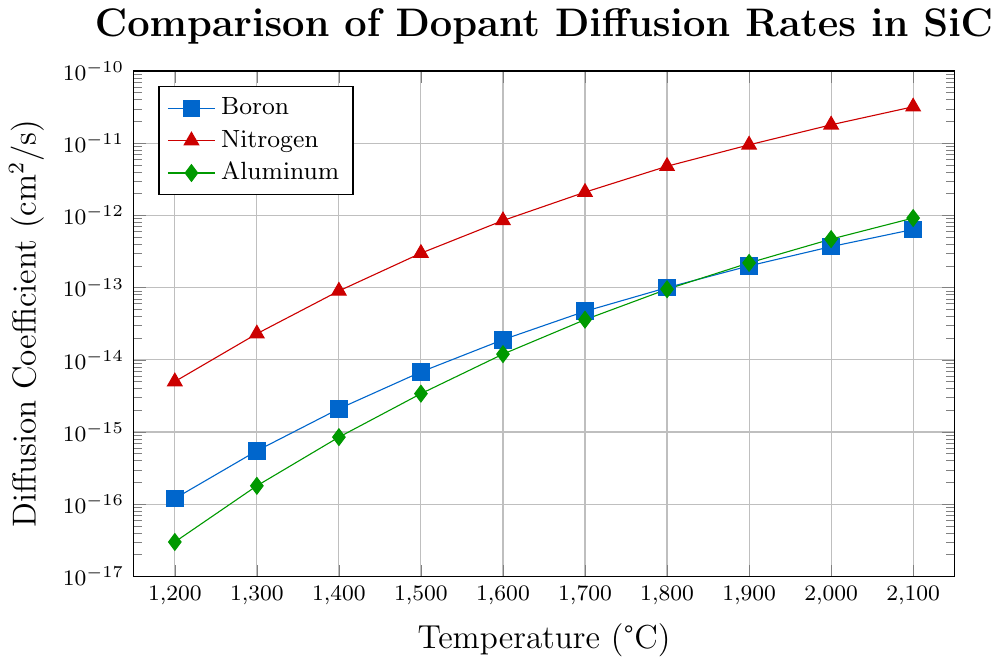What's the diffusion coefficient of Boron at 1500°C? To find the diffusion coefficient of Boron at 1500°C, look at the data point corresponding to 1500 on the x-axis in the Boron series and read off the value on the y-axis.
Answer: 6.8e-15 Which dopant has the highest diffusion rate at 1800°C? Compare the diffusion rates of Boron, Nitrogen, and Aluminum at 1800°C by looking at their values on the y-axis for this temperature. Nitrogen's diffusion rate is the highest among the three.
Answer: Nitrogen At what temperature does Boron have a diffusion coefficient of approximately 4.7e-14 cm²/s? Identify the point on the Boron series where the y-value is closest to 4.7e-14 cm²/s and look at the corresponding x-axis value (temperature).
Answer: 1700°C How does the diffusion rate of Aluminum at 2100°C compare to Boron at 1800°C? Find the diffusion rates of Aluminum at 2100°C and Boron at 1800°C. The diffusion rate for Aluminum at 2100°C is 9.2e-13 cm²/s, and for Boron at 1800°C, it is 1.0e-13 cm²/s. Compare these values.
Answer: Aluminum's rate is higher What is the average diffusion rate of Nitrogen between 1200°C and 1400°C? To calculate the average, sum up Nitrogen's diffusion rates at 1200°C (5.0e-15 cm²/s), 1300°C (2.3e-14 cm²/s), and 1400°C (9.0e-14 cm²/s), then divide by the number of data points (3). (5.0e-15 + 2.3e-14 + 9.0e-14) / 3 = 3.57e-14
Answer: 3.57e-14 Between 1500°C and 2100°C, which dopant's diffusion coefficient increases the most? Calculate the difference in diffusion coefficients for each dopant between 1500°C and 2100°C. For Boron: (6.4e-13 - 6.8e-15), for Nitrogen: (3.2e-11 - 3.0e-13), for Aluminum: (9.2e-13 - 3.4e-15). Then compare these values.
Answer: Nitrogen What can be inferred about the color representation of each dopant? Refer to the legend in the figure to determine which color represents each dopant. Boron is blue, Nitrogen is red, and Aluminum is green.
Answer: Boron is blue, Nitrogen is red, Aluminum is green What trend is observed in Boron's diffusion rate as temperature increases? Observe the shape and slope of the Boron curve as temperature increases from 1200°C to 2100°C. The diffusion rate of Boron shows an upward trend, indicating that it increases with temperature.
Answer: Increases What are the diffusion rates of all three dopants at 2000°C? Read the y-axis values at 2000°C for Boron, Nitrogen, and Aluminum. The diffusion rates are: Boron: 3.7e-13 cm²/s, Nitrogen: 1.8e-11 cm²/s, Aluminum: 4.7e-13 cm²/s.
Answer: Boron: 3.7e-13, Nitrogen: 1.8e-11, Aluminum: 4.7e-13 Which dopant shows the smallest increase in diffusion rate from 1200°C to 1300°C? Compare the diffusion rates at 1200°C and 1300°C for Boron, Nitrogen, and Aluminum. Calculate the differences and identify the smallest increase. Boron: (5.5e-16 - 1.2e-16), Nitrogen: (2.3e-14 - 5.0e-15), Aluminum: (1.8e-16 - 3.0e-17). Boron increases by 4.3e-16, Nitrogen by 1.8e-14, and Aluminum by 1.5e-16.
Answer: Aluminum 